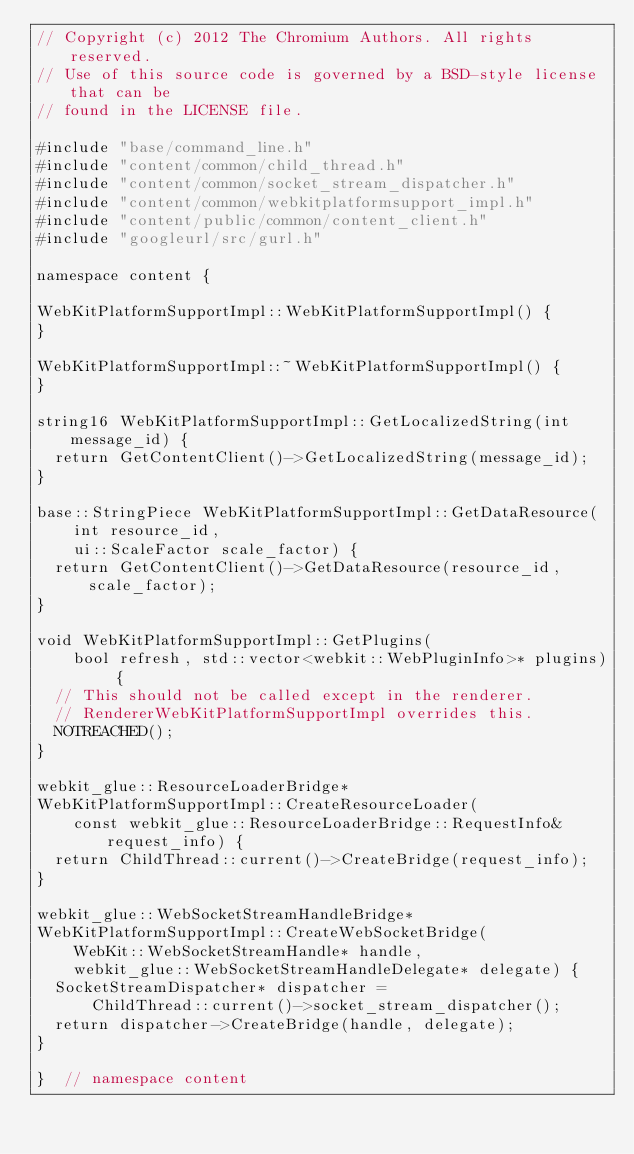Convert code to text. <code><loc_0><loc_0><loc_500><loc_500><_C++_>// Copyright (c) 2012 The Chromium Authors. All rights reserved.
// Use of this source code is governed by a BSD-style license that can be
// found in the LICENSE file.

#include "base/command_line.h"
#include "content/common/child_thread.h"
#include "content/common/socket_stream_dispatcher.h"
#include "content/common/webkitplatformsupport_impl.h"
#include "content/public/common/content_client.h"
#include "googleurl/src/gurl.h"

namespace content {

WebKitPlatformSupportImpl::WebKitPlatformSupportImpl() {
}

WebKitPlatformSupportImpl::~WebKitPlatformSupportImpl() {
}

string16 WebKitPlatformSupportImpl::GetLocalizedString(int message_id) {
  return GetContentClient()->GetLocalizedString(message_id);
}

base::StringPiece WebKitPlatformSupportImpl::GetDataResource(
    int resource_id,
    ui::ScaleFactor scale_factor) {
  return GetContentClient()->GetDataResource(resource_id, scale_factor);
}

void WebKitPlatformSupportImpl::GetPlugins(
    bool refresh, std::vector<webkit::WebPluginInfo>* plugins) {
  // This should not be called except in the renderer.
  // RendererWebKitPlatformSupportImpl overrides this.
  NOTREACHED();
}

webkit_glue::ResourceLoaderBridge*
WebKitPlatformSupportImpl::CreateResourceLoader(
    const webkit_glue::ResourceLoaderBridge::RequestInfo& request_info) {
  return ChildThread::current()->CreateBridge(request_info);
}

webkit_glue::WebSocketStreamHandleBridge*
WebKitPlatformSupportImpl::CreateWebSocketBridge(
    WebKit::WebSocketStreamHandle* handle,
    webkit_glue::WebSocketStreamHandleDelegate* delegate) {
  SocketStreamDispatcher* dispatcher =
      ChildThread::current()->socket_stream_dispatcher();
  return dispatcher->CreateBridge(handle, delegate);
}

}  // namespace content
</code> 